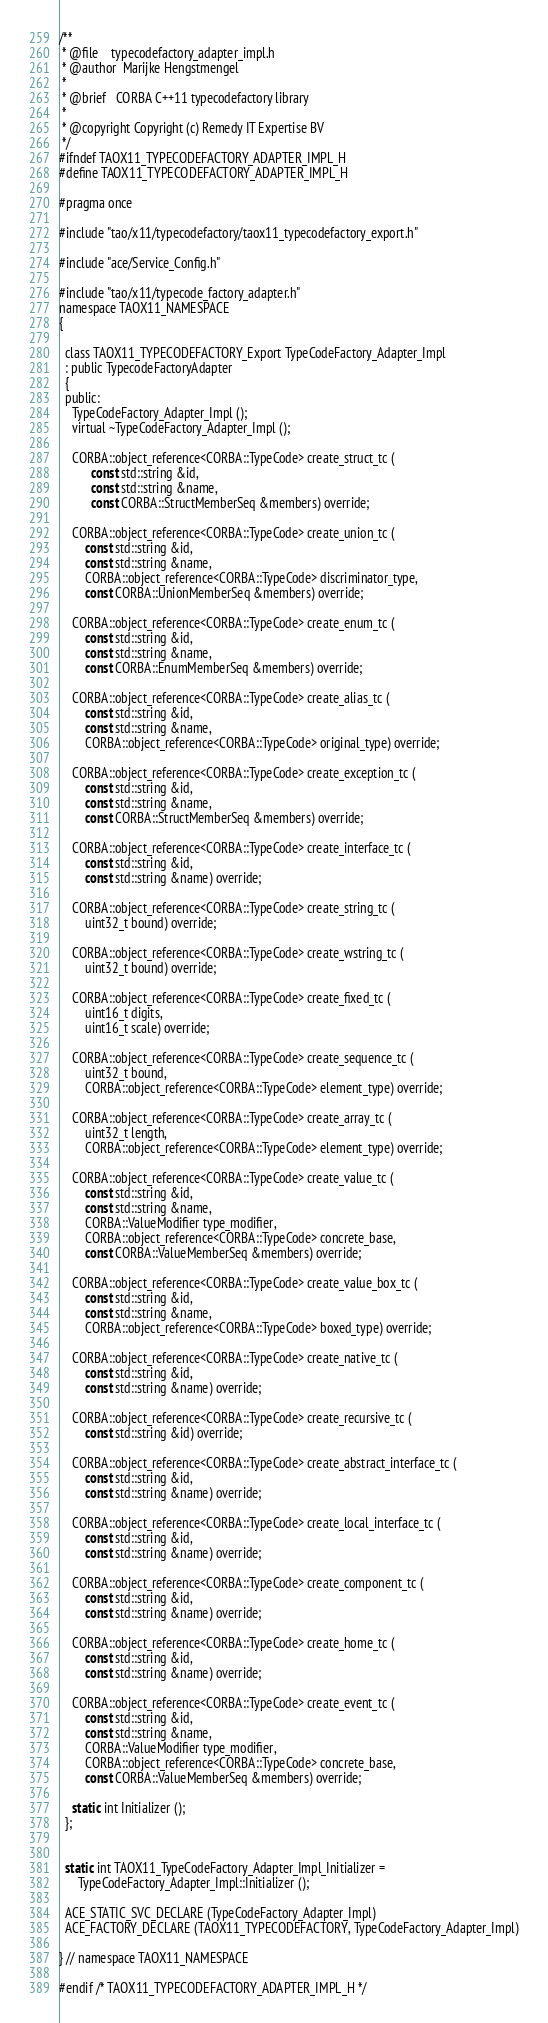<code> <loc_0><loc_0><loc_500><loc_500><_C_>/**
 * @file    typecodefactory_adapter_impl.h
 * @author  Marijke Hengstmengel
 *
 * @brief   CORBA C++11 typecodefactory library
 *
 * @copyright Copyright (c) Remedy IT Expertise BV
 */
#ifndef TAOX11_TYPECODEFACTORY_ADAPTER_IMPL_H
#define TAOX11_TYPECODEFACTORY_ADAPTER_IMPL_H

#pragma once

#include "tao/x11/typecodefactory/taox11_typecodefactory_export.h"

#include "ace/Service_Config.h"

#include "tao/x11/typecode_factory_adapter.h"
namespace TAOX11_NAMESPACE
{

  class TAOX11_TYPECODEFACTORY_Export TypeCodeFactory_Adapter_Impl
  : public TypecodeFactoryAdapter
  {
  public:
    TypeCodeFactory_Adapter_Impl ();
    virtual ~TypeCodeFactory_Adapter_Impl ();

    CORBA::object_reference<CORBA::TypeCode> create_struct_tc (
          const std::string &id,
          const std::string &name,
          const CORBA::StructMemberSeq &members) override;

    CORBA::object_reference<CORBA::TypeCode> create_union_tc (
        const std::string &id,
        const std::string &name,
        CORBA::object_reference<CORBA::TypeCode> discriminator_type,
        const CORBA::UnionMemberSeq &members) override;

    CORBA::object_reference<CORBA::TypeCode> create_enum_tc (
        const std::string &id,
        const std::string &name,
        const CORBA::EnumMemberSeq &members) override;

    CORBA::object_reference<CORBA::TypeCode> create_alias_tc (
        const std::string &id,
        const std::string &name,
        CORBA::object_reference<CORBA::TypeCode> original_type) override;

    CORBA::object_reference<CORBA::TypeCode> create_exception_tc (
        const std::string &id,
        const std::string &name,
        const CORBA::StructMemberSeq &members) override;

    CORBA::object_reference<CORBA::TypeCode> create_interface_tc (
        const std::string &id,
        const std::string &name) override;

    CORBA::object_reference<CORBA::TypeCode> create_string_tc (
        uint32_t bound) override;

    CORBA::object_reference<CORBA::TypeCode> create_wstring_tc (
        uint32_t bound) override;

    CORBA::object_reference<CORBA::TypeCode> create_fixed_tc (
        uint16_t digits,
        uint16_t scale) override;

    CORBA::object_reference<CORBA::TypeCode> create_sequence_tc (
        uint32_t bound,
        CORBA::object_reference<CORBA::TypeCode> element_type) override;

    CORBA::object_reference<CORBA::TypeCode> create_array_tc (
        uint32_t length,
        CORBA::object_reference<CORBA::TypeCode> element_type) override;

    CORBA::object_reference<CORBA::TypeCode> create_value_tc (
        const std::string &id,
        const std::string &name,
        CORBA::ValueModifier type_modifier,
        CORBA::object_reference<CORBA::TypeCode> concrete_base,
        const CORBA::ValueMemberSeq &members) override;

    CORBA::object_reference<CORBA::TypeCode> create_value_box_tc (
        const std::string &id,
        const std::string &name,
        CORBA::object_reference<CORBA::TypeCode> boxed_type) override;

    CORBA::object_reference<CORBA::TypeCode> create_native_tc (
        const std::string &id,
        const std::string &name) override;

    CORBA::object_reference<CORBA::TypeCode> create_recursive_tc (
        const std::string &id) override;

    CORBA::object_reference<CORBA::TypeCode> create_abstract_interface_tc (
        const std::string &id,
        const std::string &name) override;

    CORBA::object_reference<CORBA::TypeCode> create_local_interface_tc (
        const std::string &id,
        const std::string &name) override;

    CORBA::object_reference<CORBA::TypeCode> create_component_tc (
        const std::string &id,
        const std::string &name) override;

    CORBA::object_reference<CORBA::TypeCode> create_home_tc (
        const std::string &id,
        const std::string &name) override;

    CORBA::object_reference<CORBA::TypeCode> create_event_tc (
        const std::string &id,
        const std::string &name,
        CORBA::ValueModifier type_modifier,
        CORBA::object_reference<CORBA::TypeCode> concrete_base,
        const CORBA::ValueMemberSeq &members) override;

    static int Initializer ();
  };


  static int TAOX11_TypeCodeFactory_Adapter_Impl_Initializer =
      TypeCodeFactory_Adapter_Impl::Initializer ();

  ACE_STATIC_SVC_DECLARE (TypeCodeFactory_Adapter_Impl)
  ACE_FACTORY_DECLARE (TAOX11_TYPECODEFACTORY, TypeCodeFactory_Adapter_Impl)

} // namespace TAOX11_NAMESPACE

#endif /* TAOX11_TYPECODEFACTORY_ADAPTER_IMPL_H */
</code> 